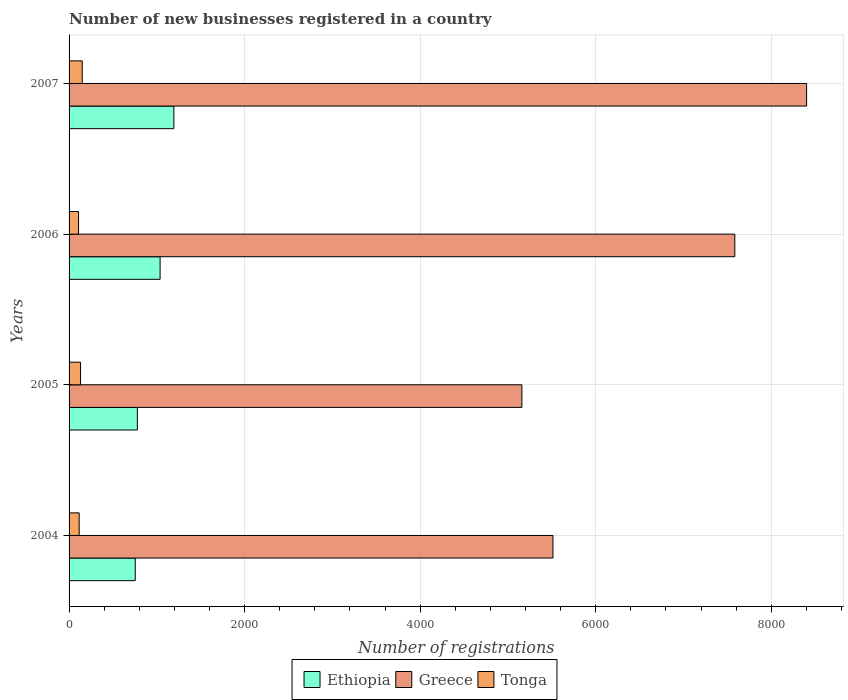Are the number of bars on each tick of the Y-axis equal?
Provide a short and direct response. Yes. How many bars are there on the 1st tick from the bottom?
Offer a very short reply. 3. What is the label of the 4th group of bars from the top?
Your response must be concise. 2004. What is the number of new businesses registered in Greece in 2005?
Keep it short and to the point. 5159. Across all years, what is the maximum number of new businesses registered in Tonga?
Your response must be concise. 150. Across all years, what is the minimum number of new businesses registered in Tonga?
Your response must be concise. 108. In which year was the number of new businesses registered in Tonga maximum?
Offer a terse response. 2007. What is the total number of new businesses registered in Tonga in the graph?
Ensure brevity in your answer.  504. What is the difference between the number of new businesses registered in Tonga in 2005 and that in 2007?
Offer a very short reply. -19. What is the difference between the number of new businesses registered in Ethiopia in 2004 and the number of new businesses registered in Tonga in 2005?
Provide a succinct answer. 623. What is the average number of new businesses registered in Ethiopia per year?
Provide a succinct answer. 940.75. In the year 2005, what is the difference between the number of new businesses registered in Tonga and number of new businesses registered in Greece?
Provide a succinct answer. -5028. What is the ratio of the number of new businesses registered in Ethiopia in 2004 to that in 2006?
Ensure brevity in your answer.  0.73. What is the difference between the highest and the second highest number of new businesses registered in Greece?
Offer a very short reply. 818. What is the difference between the highest and the lowest number of new businesses registered in Ethiopia?
Your answer should be very brief. 440. In how many years, is the number of new businesses registered in Ethiopia greater than the average number of new businesses registered in Ethiopia taken over all years?
Make the answer very short. 2. Is the sum of the number of new businesses registered in Greece in 2005 and 2007 greater than the maximum number of new businesses registered in Tonga across all years?
Provide a succinct answer. Yes. What does the 1st bar from the top in 2004 represents?
Your answer should be compact. Tonga. What does the 3rd bar from the bottom in 2007 represents?
Ensure brevity in your answer.  Tonga. How many bars are there?
Your answer should be compact. 12. Are all the bars in the graph horizontal?
Your response must be concise. Yes. What is the difference between two consecutive major ticks on the X-axis?
Provide a short and direct response. 2000. Does the graph contain any zero values?
Your response must be concise. No. Does the graph contain grids?
Your answer should be compact. Yes. Where does the legend appear in the graph?
Provide a short and direct response. Bottom center. How are the legend labels stacked?
Offer a very short reply. Horizontal. What is the title of the graph?
Provide a succinct answer. Number of new businesses registered in a country. Does "Euro area" appear as one of the legend labels in the graph?
Offer a terse response. No. What is the label or title of the X-axis?
Make the answer very short. Number of registrations. What is the label or title of the Y-axis?
Your response must be concise. Years. What is the Number of registrations in Ethiopia in 2004?
Give a very brief answer. 754. What is the Number of registrations of Greece in 2004?
Offer a very short reply. 5513. What is the Number of registrations of Tonga in 2004?
Make the answer very short. 115. What is the Number of registrations in Ethiopia in 2005?
Make the answer very short. 778. What is the Number of registrations of Greece in 2005?
Provide a succinct answer. 5159. What is the Number of registrations in Tonga in 2005?
Give a very brief answer. 131. What is the Number of registrations of Ethiopia in 2006?
Your response must be concise. 1037. What is the Number of registrations of Greece in 2006?
Offer a terse response. 7585. What is the Number of registrations of Tonga in 2006?
Give a very brief answer. 108. What is the Number of registrations in Ethiopia in 2007?
Your answer should be very brief. 1194. What is the Number of registrations in Greece in 2007?
Your response must be concise. 8403. What is the Number of registrations of Tonga in 2007?
Give a very brief answer. 150. Across all years, what is the maximum Number of registrations in Ethiopia?
Your answer should be compact. 1194. Across all years, what is the maximum Number of registrations in Greece?
Ensure brevity in your answer.  8403. Across all years, what is the maximum Number of registrations in Tonga?
Your answer should be compact. 150. Across all years, what is the minimum Number of registrations of Ethiopia?
Offer a very short reply. 754. Across all years, what is the minimum Number of registrations of Greece?
Ensure brevity in your answer.  5159. Across all years, what is the minimum Number of registrations in Tonga?
Offer a very short reply. 108. What is the total Number of registrations in Ethiopia in the graph?
Provide a succinct answer. 3763. What is the total Number of registrations of Greece in the graph?
Ensure brevity in your answer.  2.67e+04. What is the total Number of registrations of Tonga in the graph?
Offer a terse response. 504. What is the difference between the Number of registrations in Greece in 2004 and that in 2005?
Provide a succinct answer. 354. What is the difference between the Number of registrations of Tonga in 2004 and that in 2005?
Make the answer very short. -16. What is the difference between the Number of registrations in Ethiopia in 2004 and that in 2006?
Your answer should be compact. -283. What is the difference between the Number of registrations in Greece in 2004 and that in 2006?
Your answer should be compact. -2072. What is the difference between the Number of registrations of Tonga in 2004 and that in 2006?
Provide a succinct answer. 7. What is the difference between the Number of registrations in Ethiopia in 2004 and that in 2007?
Your answer should be very brief. -440. What is the difference between the Number of registrations of Greece in 2004 and that in 2007?
Your response must be concise. -2890. What is the difference between the Number of registrations of Tonga in 2004 and that in 2007?
Your answer should be very brief. -35. What is the difference between the Number of registrations of Ethiopia in 2005 and that in 2006?
Provide a succinct answer. -259. What is the difference between the Number of registrations in Greece in 2005 and that in 2006?
Your response must be concise. -2426. What is the difference between the Number of registrations in Ethiopia in 2005 and that in 2007?
Make the answer very short. -416. What is the difference between the Number of registrations of Greece in 2005 and that in 2007?
Provide a short and direct response. -3244. What is the difference between the Number of registrations in Ethiopia in 2006 and that in 2007?
Your answer should be very brief. -157. What is the difference between the Number of registrations in Greece in 2006 and that in 2007?
Your answer should be very brief. -818. What is the difference between the Number of registrations in Tonga in 2006 and that in 2007?
Your answer should be very brief. -42. What is the difference between the Number of registrations of Ethiopia in 2004 and the Number of registrations of Greece in 2005?
Provide a short and direct response. -4405. What is the difference between the Number of registrations of Ethiopia in 2004 and the Number of registrations of Tonga in 2005?
Your answer should be compact. 623. What is the difference between the Number of registrations in Greece in 2004 and the Number of registrations in Tonga in 2005?
Your answer should be compact. 5382. What is the difference between the Number of registrations in Ethiopia in 2004 and the Number of registrations in Greece in 2006?
Your answer should be very brief. -6831. What is the difference between the Number of registrations in Ethiopia in 2004 and the Number of registrations in Tonga in 2006?
Offer a terse response. 646. What is the difference between the Number of registrations in Greece in 2004 and the Number of registrations in Tonga in 2006?
Your answer should be very brief. 5405. What is the difference between the Number of registrations in Ethiopia in 2004 and the Number of registrations in Greece in 2007?
Provide a succinct answer. -7649. What is the difference between the Number of registrations in Ethiopia in 2004 and the Number of registrations in Tonga in 2007?
Offer a very short reply. 604. What is the difference between the Number of registrations of Greece in 2004 and the Number of registrations of Tonga in 2007?
Offer a terse response. 5363. What is the difference between the Number of registrations of Ethiopia in 2005 and the Number of registrations of Greece in 2006?
Offer a terse response. -6807. What is the difference between the Number of registrations of Ethiopia in 2005 and the Number of registrations of Tonga in 2006?
Offer a terse response. 670. What is the difference between the Number of registrations of Greece in 2005 and the Number of registrations of Tonga in 2006?
Provide a short and direct response. 5051. What is the difference between the Number of registrations of Ethiopia in 2005 and the Number of registrations of Greece in 2007?
Your response must be concise. -7625. What is the difference between the Number of registrations of Ethiopia in 2005 and the Number of registrations of Tonga in 2007?
Your answer should be very brief. 628. What is the difference between the Number of registrations of Greece in 2005 and the Number of registrations of Tonga in 2007?
Your response must be concise. 5009. What is the difference between the Number of registrations in Ethiopia in 2006 and the Number of registrations in Greece in 2007?
Keep it short and to the point. -7366. What is the difference between the Number of registrations of Ethiopia in 2006 and the Number of registrations of Tonga in 2007?
Make the answer very short. 887. What is the difference between the Number of registrations in Greece in 2006 and the Number of registrations in Tonga in 2007?
Provide a succinct answer. 7435. What is the average Number of registrations in Ethiopia per year?
Make the answer very short. 940.75. What is the average Number of registrations in Greece per year?
Your response must be concise. 6665. What is the average Number of registrations in Tonga per year?
Offer a terse response. 126. In the year 2004, what is the difference between the Number of registrations of Ethiopia and Number of registrations of Greece?
Your answer should be compact. -4759. In the year 2004, what is the difference between the Number of registrations of Ethiopia and Number of registrations of Tonga?
Offer a terse response. 639. In the year 2004, what is the difference between the Number of registrations in Greece and Number of registrations in Tonga?
Offer a very short reply. 5398. In the year 2005, what is the difference between the Number of registrations of Ethiopia and Number of registrations of Greece?
Make the answer very short. -4381. In the year 2005, what is the difference between the Number of registrations in Ethiopia and Number of registrations in Tonga?
Offer a terse response. 647. In the year 2005, what is the difference between the Number of registrations of Greece and Number of registrations of Tonga?
Ensure brevity in your answer.  5028. In the year 2006, what is the difference between the Number of registrations in Ethiopia and Number of registrations in Greece?
Offer a very short reply. -6548. In the year 2006, what is the difference between the Number of registrations in Ethiopia and Number of registrations in Tonga?
Make the answer very short. 929. In the year 2006, what is the difference between the Number of registrations of Greece and Number of registrations of Tonga?
Ensure brevity in your answer.  7477. In the year 2007, what is the difference between the Number of registrations in Ethiopia and Number of registrations in Greece?
Your answer should be compact. -7209. In the year 2007, what is the difference between the Number of registrations of Ethiopia and Number of registrations of Tonga?
Your answer should be compact. 1044. In the year 2007, what is the difference between the Number of registrations in Greece and Number of registrations in Tonga?
Your answer should be compact. 8253. What is the ratio of the Number of registrations of Ethiopia in 2004 to that in 2005?
Offer a terse response. 0.97. What is the ratio of the Number of registrations of Greece in 2004 to that in 2005?
Ensure brevity in your answer.  1.07. What is the ratio of the Number of registrations in Tonga in 2004 to that in 2005?
Provide a succinct answer. 0.88. What is the ratio of the Number of registrations in Ethiopia in 2004 to that in 2006?
Make the answer very short. 0.73. What is the ratio of the Number of registrations of Greece in 2004 to that in 2006?
Keep it short and to the point. 0.73. What is the ratio of the Number of registrations of Tonga in 2004 to that in 2006?
Offer a terse response. 1.06. What is the ratio of the Number of registrations in Ethiopia in 2004 to that in 2007?
Your answer should be compact. 0.63. What is the ratio of the Number of registrations in Greece in 2004 to that in 2007?
Your answer should be compact. 0.66. What is the ratio of the Number of registrations in Tonga in 2004 to that in 2007?
Provide a succinct answer. 0.77. What is the ratio of the Number of registrations of Ethiopia in 2005 to that in 2006?
Your response must be concise. 0.75. What is the ratio of the Number of registrations in Greece in 2005 to that in 2006?
Keep it short and to the point. 0.68. What is the ratio of the Number of registrations in Tonga in 2005 to that in 2006?
Make the answer very short. 1.21. What is the ratio of the Number of registrations in Ethiopia in 2005 to that in 2007?
Provide a short and direct response. 0.65. What is the ratio of the Number of registrations of Greece in 2005 to that in 2007?
Give a very brief answer. 0.61. What is the ratio of the Number of registrations of Tonga in 2005 to that in 2007?
Give a very brief answer. 0.87. What is the ratio of the Number of registrations of Ethiopia in 2006 to that in 2007?
Offer a terse response. 0.87. What is the ratio of the Number of registrations in Greece in 2006 to that in 2007?
Ensure brevity in your answer.  0.9. What is the ratio of the Number of registrations in Tonga in 2006 to that in 2007?
Provide a short and direct response. 0.72. What is the difference between the highest and the second highest Number of registrations in Ethiopia?
Offer a very short reply. 157. What is the difference between the highest and the second highest Number of registrations in Greece?
Provide a succinct answer. 818. What is the difference between the highest and the lowest Number of registrations in Ethiopia?
Your response must be concise. 440. What is the difference between the highest and the lowest Number of registrations of Greece?
Provide a short and direct response. 3244. 